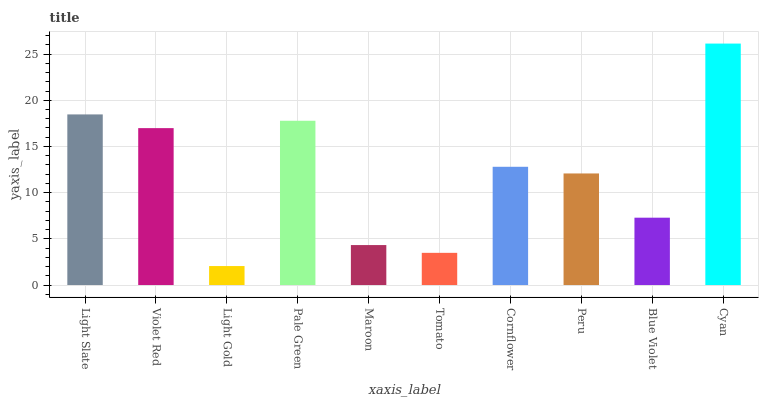Is Light Gold the minimum?
Answer yes or no. Yes. Is Cyan the maximum?
Answer yes or no. Yes. Is Violet Red the minimum?
Answer yes or no. No. Is Violet Red the maximum?
Answer yes or no. No. Is Light Slate greater than Violet Red?
Answer yes or no. Yes. Is Violet Red less than Light Slate?
Answer yes or no. Yes. Is Violet Red greater than Light Slate?
Answer yes or no. No. Is Light Slate less than Violet Red?
Answer yes or no. No. Is Cornflower the high median?
Answer yes or no. Yes. Is Peru the low median?
Answer yes or no. Yes. Is Peru the high median?
Answer yes or no. No. Is Maroon the low median?
Answer yes or no. No. 